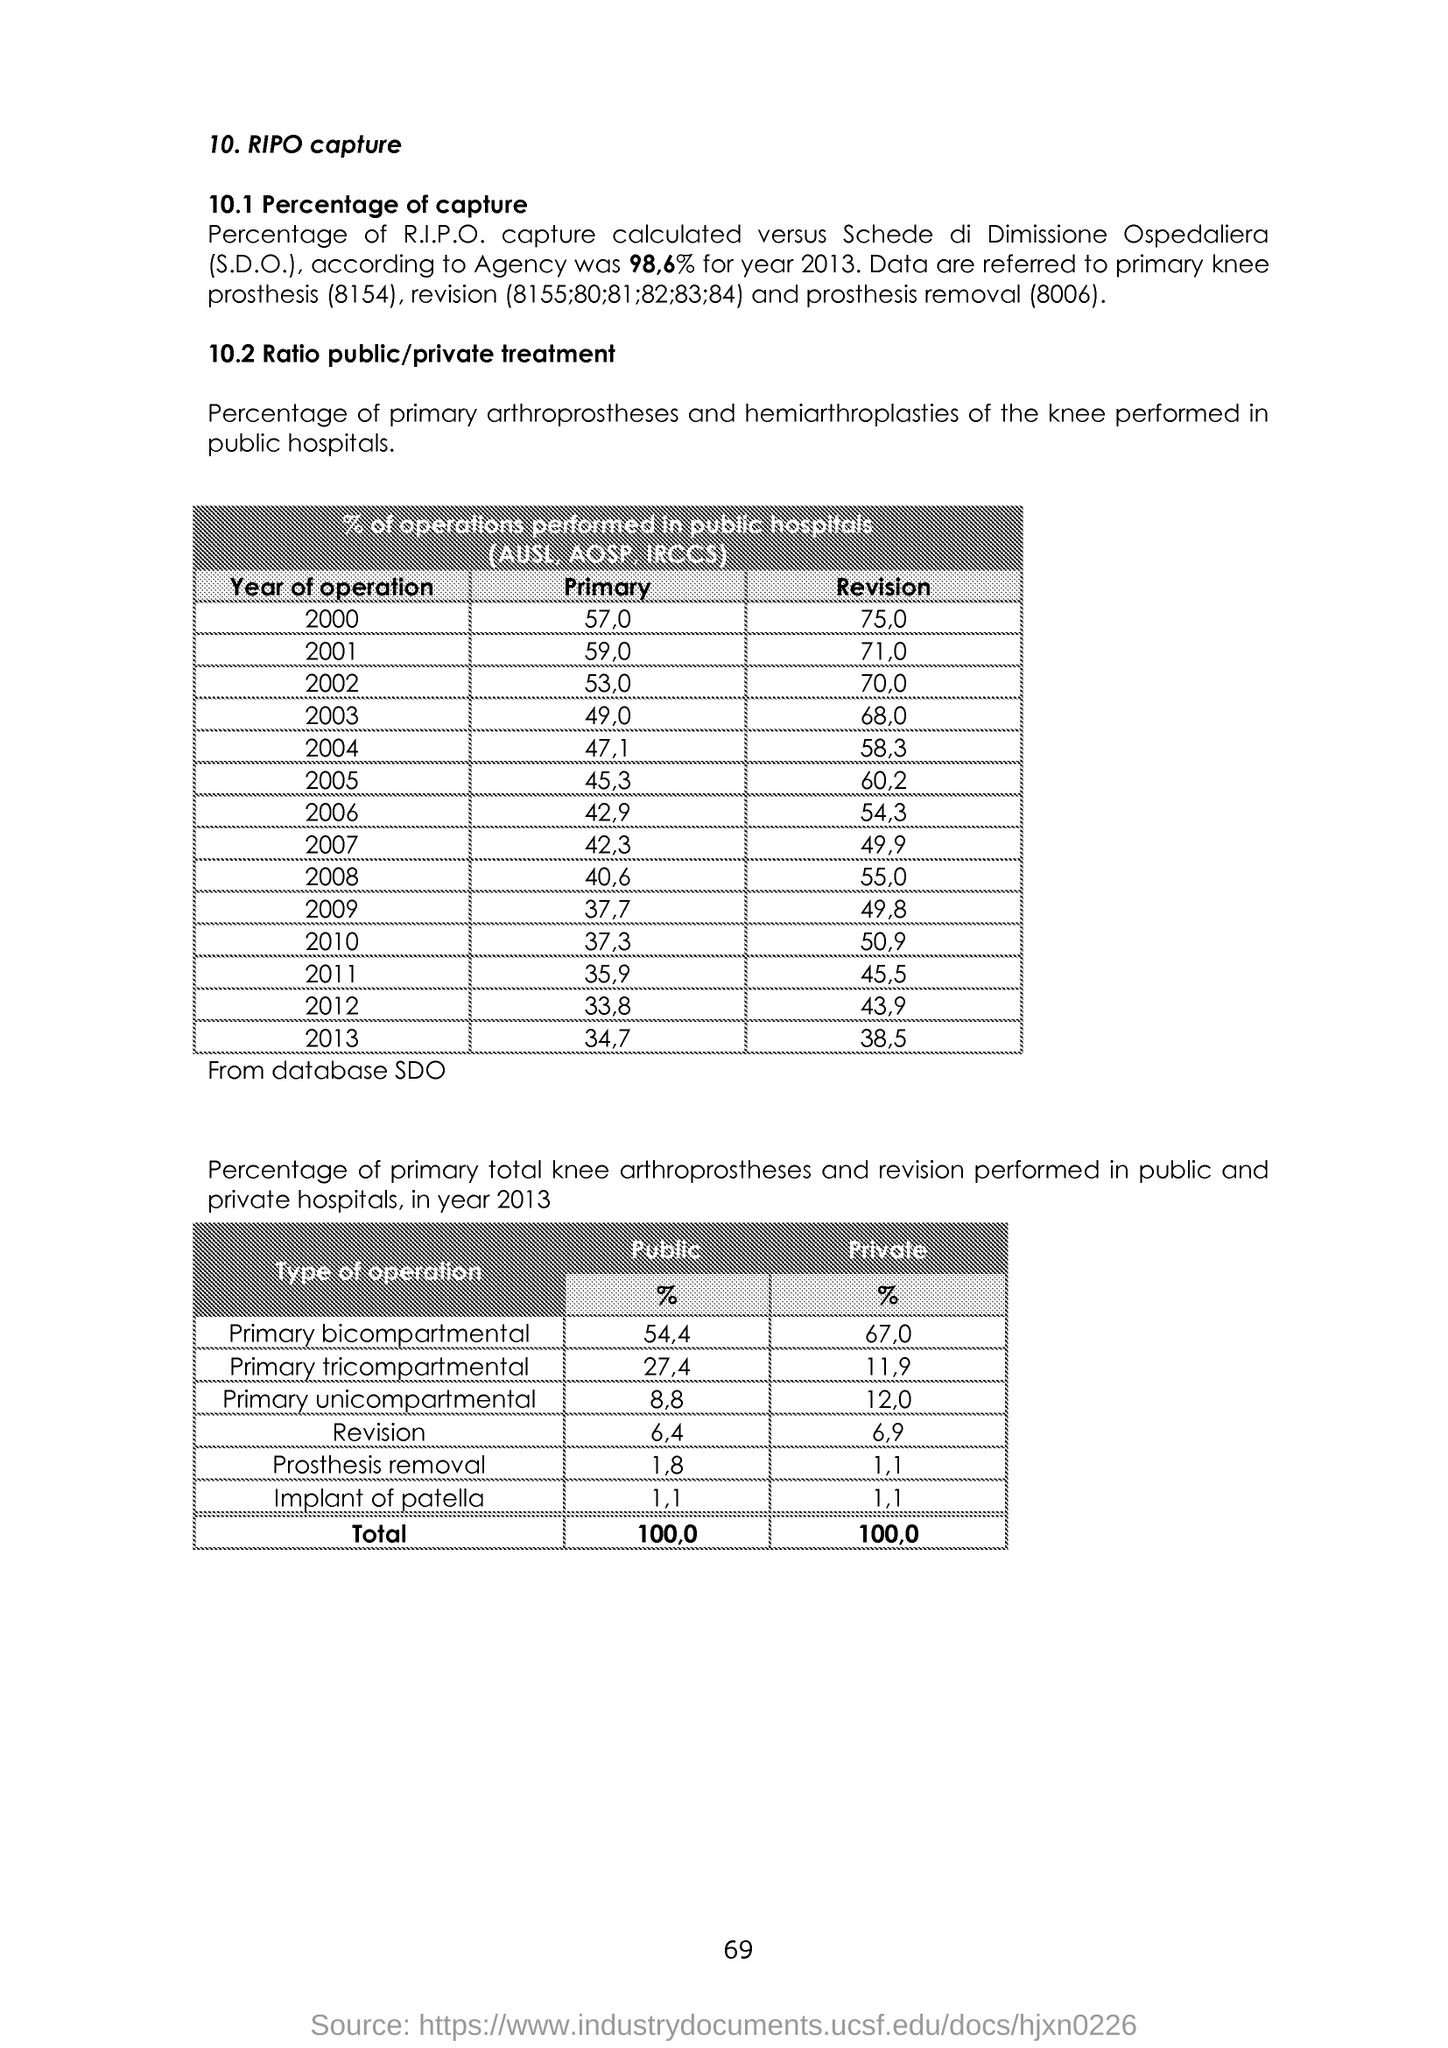What is the number at bottom of the page ?
Your answer should be very brief. 69. What is the public % of primary bicompartmental ?
Keep it short and to the point. 54,4. What is the public % of primary tricompartmental ?
Ensure brevity in your answer.  27,4. What is the public % of primary unicompartmental ?
Offer a terse response. 8,8. What is the public % of revision ?
Provide a succinct answer. 6,4. What is the public % of prosthesis removal ?
Make the answer very short. 1,8. What is the public % of implant of patella ?
Provide a short and direct response. 1,1. What is the private % of primary bicompartmental ?
Offer a very short reply. 67,0. What is the private % of primary tricompartmental ?
Your answer should be compact. 11,9. What is the private % of primary unicompartmental ?
Ensure brevity in your answer.  12,0. 